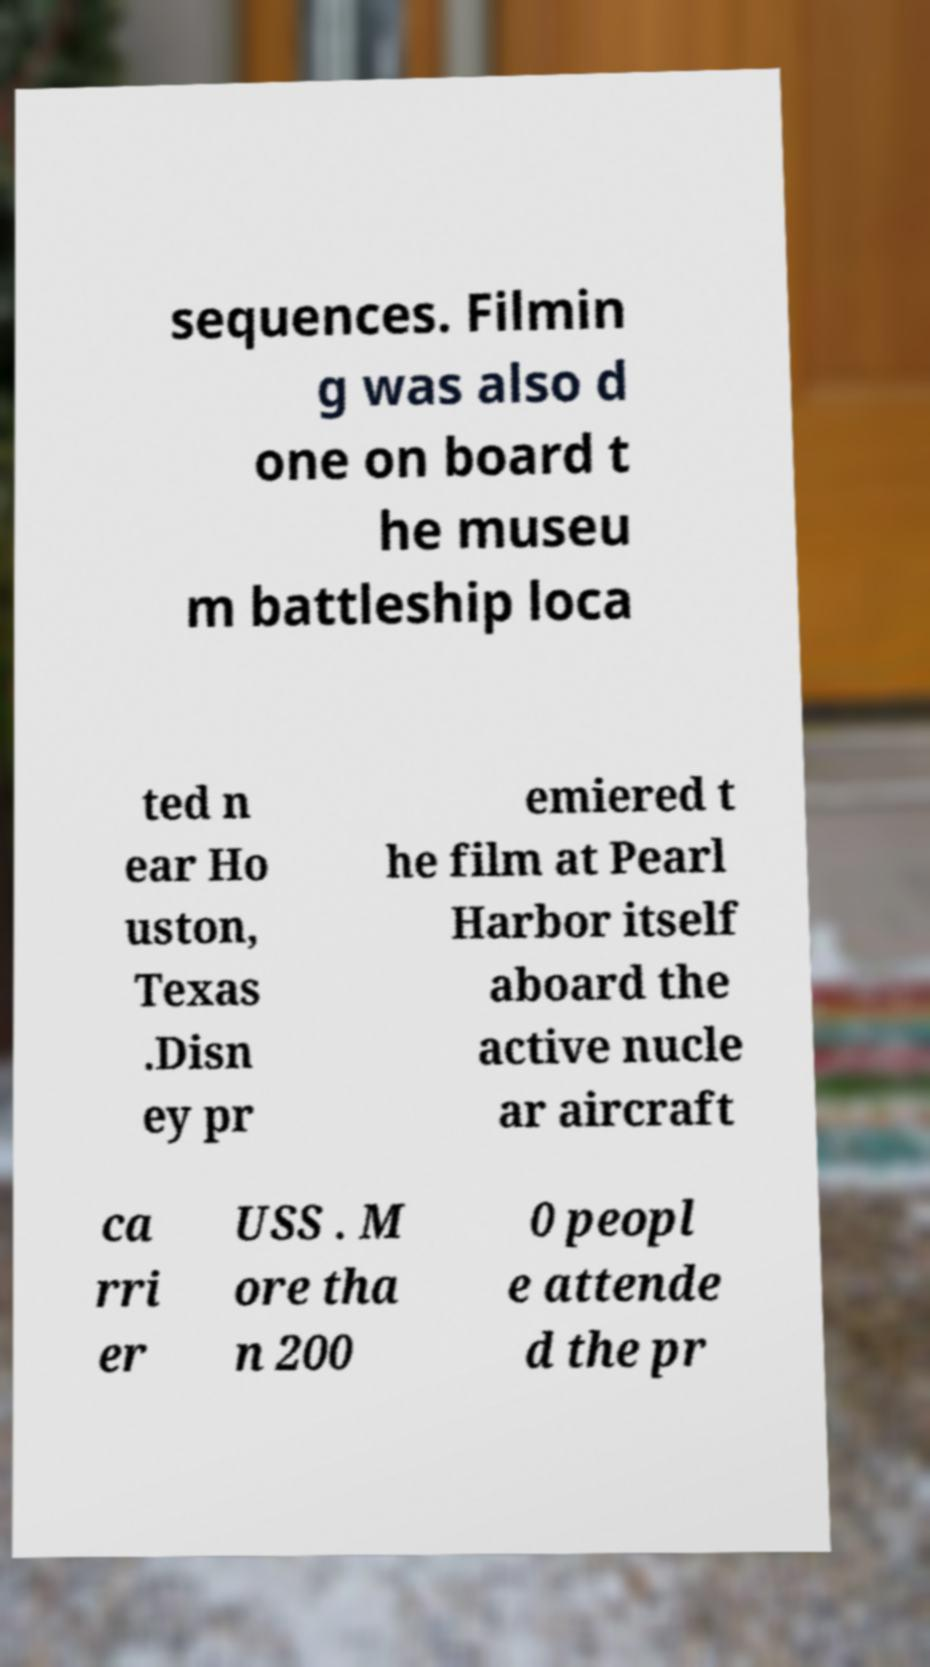For documentation purposes, I need the text within this image transcribed. Could you provide that? sequences. Filmin g was also d one on board t he museu m battleship loca ted n ear Ho uston, Texas .Disn ey pr emiered t he film at Pearl Harbor itself aboard the active nucle ar aircraft ca rri er USS . M ore tha n 200 0 peopl e attende d the pr 